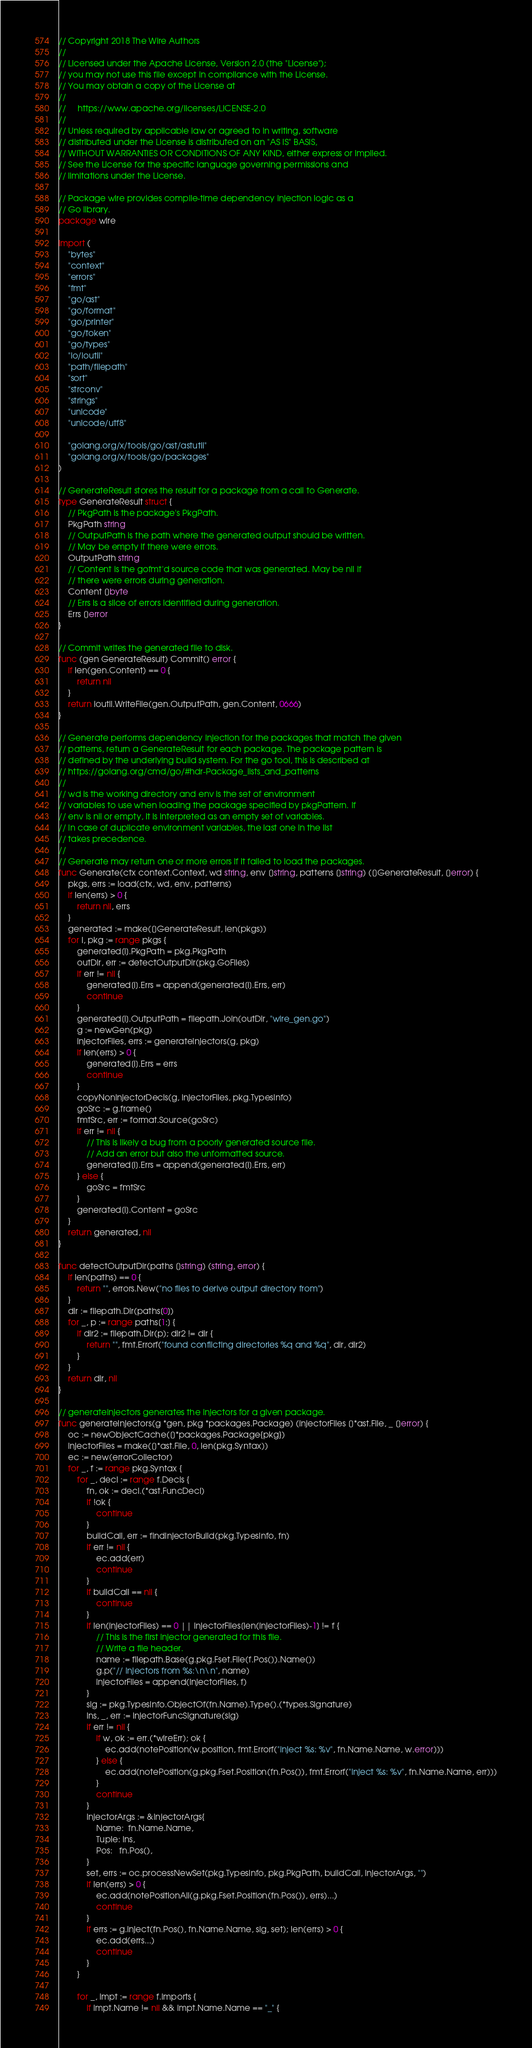Convert code to text. <code><loc_0><loc_0><loc_500><loc_500><_Go_>// Copyright 2018 The Wire Authors
//
// Licensed under the Apache License, Version 2.0 (the "License");
// you may not use this file except in compliance with the License.
// You may obtain a copy of the License at
//
//     https://www.apache.org/licenses/LICENSE-2.0
//
// Unless required by applicable law or agreed to in writing, software
// distributed under the License is distributed on an "AS IS" BASIS,
// WITHOUT WARRANTIES OR CONDITIONS OF ANY KIND, either express or implied.
// See the License for the specific language governing permissions and
// limitations under the License.

// Package wire provides compile-time dependency injection logic as a
// Go library.
package wire

import (
	"bytes"
	"context"
	"errors"
	"fmt"
	"go/ast"
	"go/format"
	"go/printer"
	"go/token"
	"go/types"
	"io/ioutil"
	"path/filepath"
	"sort"
	"strconv"
	"strings"
	"unicode"
	"unicode/utf8"

	"golang.org/x/tools/go/ast/astutil"
	"golang.org/x/tools/go/packages"
)

// GenerateResult stores the result for a package from a call to Generate.
type GenerateResult struct {
	// PkgPath is the package's PkgPath.
	PkgPath string
	// OutputPath is the path where the generated output should be written.
	// May be empty if there were errors.
	OutputPath string
	// Content is the gofmt'd source code that was generated. May be nil if
	// there were errors during generation.
	Content []byte
	// Errs is a slice of errors identified during generation.
	Errs []error
}

// Commit writes the generated file to disk.
func (gen GenerateResult) Commit() error {
	if len(gen.Content) == 0 {
		return nil
	}
	return ioutil.WriteFile(gen.OutputPath, gen.Content, 0666)
}

// Generate performs dependency injection for the packages that match the given
// patterns, return a GenerateResult for each package. The package pattern is
// defined by the underlying build system. For the go tool, this is described at
// https://golang.org/cmd/go/#hdr-Package_lists_and_patterns
//
// wd is the working directory and env is the set of environment
// variables to use when loading the package specified by pkgPattern. If
// env is nil or empty, it is interpreted as an empty set of variables.
// In case of duplicate environment variables, the last one in the list
// takes precedence.
//
// Generate may return one or more errors if it failed to load the packages.
func Generate(ctx context.Context, wd string, env []string, patterns []string) ([]GenerateResult, []error) {
	pkgs, errs := load(ctx, wd, env, patterns)
	if len(errs) > 0 {
		return nil, errs
	}
	generated := make([]GenerateResult, len(pkgs))
	for i, pkg := range pkgs {
		generated[i].PkgPath = pkg.PkgPath
		outDir, err := detectOutputDir(pkg.GoFiles)
		if err != nil {
			generated[i].Errs = append(generated[i].Errs, err)
			continue
		}
		generated[i].OutputPath = filepath.Join(outDir, "wire_gen.go")
		g := newGen(pkg)
		injectorFiles, errs := generateInjectors(g, pkg)
		if len(errs) > 0 {
			generated[i].Errs = errs
			continue
		}
		copyNonInjectorDecls(g, injectorFiles, pkg.TypesInfo)
		goSrc := g.frame()
		fmtSrc, err := format.Source(goSrc)
		if err != nil {
			// This is likely a bug from a poorly generated source file.
			// Add an error but also the unformatted source.
			generated[i].Errs = append(generated[i].Errs, err)
		} else {
			goSrc = fmtSrc
		}
		generated[i].Content = goSrc
	}
	return generated, nil
}

func detectOutputDir(paths []string) (string, error) {
	if len(paths) == 0 {
		return "", errors.New("no files to derive output directory from")
	}
	dir := filepath.Dir(paths[0])
	for _, p := range paths[1:] {
		if dir2 := filepath.Dir(p); dir2 != dir {
			return "", fmt.Errorf("found conflicting directories %q and %q", dir, dir2)
		}
	}
	return dir, nil
}

// generateInjectors generates the injectors for a given package.
func generateInjectors(g *gen, pkg *packages.Package) (injectorFiles []*ast.File, _ []error) {
	oc := newObjectCache([]*packages.Package{pkg})
	injectorFiles = make([]*ast.File, 0, len(pkg.Syntax))
	ec := new(errorCollector)
	for _, f := range pkg.Syntax {
		for _, decl := range f.Decls {
			fn, ok := decl.(*ast.FuncDecl)
			if !ok {
				continue
			}
			buildCall, err := findInjectorBuild(pkg.TypesInfo, fn)
			if err != nil {
				ec.add(err)
				continue
			}
			if buildCall == nil {
				continue
			}
			if len(injectorFiles) == 0 || injectorFiles[len(injectorFiles)-1] != f {
				// This is the first injector generated for this file.
				// Write a file header.
				name := filepath.Base(g.pkg.Fset.File(f.Pos()).Name())
				g.p("// Injectors from %s:\n\n", name)
				injectorFiles = append(injectorFiles, f)
			}
			sig := pkg.TypesInfo.ObjectOf(fn.Name).Type().(*types.Signature)
			ins, _, err := injectorFuncSignature(sig)
			if err != nil {
				if w, ok := err.(*wireErr); ok {
					ec.add(notePosition(w.position, fmt.Errorf("inject %s: %v", fn.Name.Name, w.error)))
				} else {
					ec.add(notePosition(g.pkg.Fset.Position(fn.Pos()), fmt.Errorf("inject %s: %v", fn.Name.Name, err)))
				}
				continue
			}
			injectorArgs := &InjectorArgs{
				Name:  fn.Name.Name,
				Tuple: ins,
				Pos:   fn.Pos(),
			}
			set, errs := oc.processNewSet(pkg.TypesInfo, pkg.PkgPath, buildCall, injectorArgs, "")
			if len(errs) > 0 {
				ec.add(notePositionAll(g.pkg.Fset.Position(fn.Pos()), errs)...)
				continue
			}
			if errs := g.inject(fn.Pos(), fn.Name.Name, sig, set); len(errs) > 0 {
				ec.add(errs...)
				continue
			}
		}

		for _, impt := range f.Imports {
			if impt.Name != nil && impt.Name.Name == "_" {</code> 